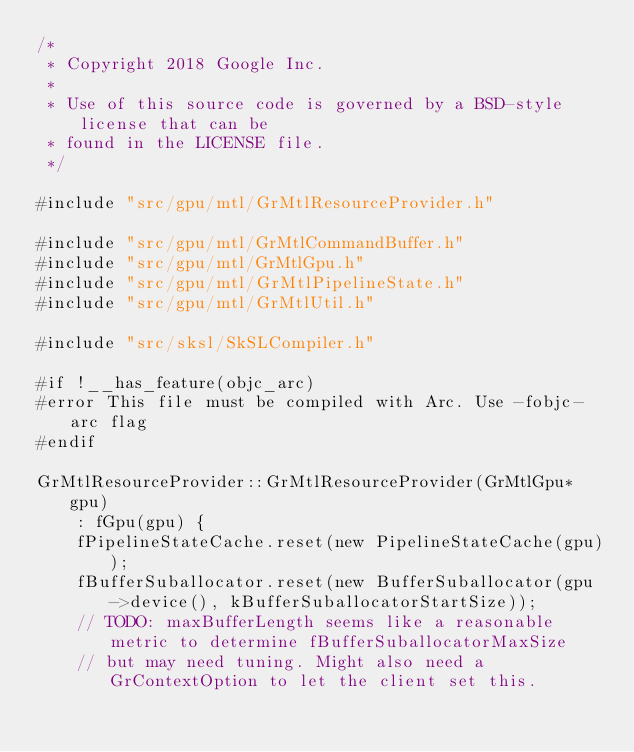Convert code to text. <code><loc_0><loc_0><loc_500><loc_500><_ObjectiveC_>/*
 * Copyright 2018 Google Inc.
 *
 * Use of this source code is governed by a BSD-style license that can be
 * found in the LICENSE file.
 */

#include "src/gpu/mtl/GrMtlResourceProvider.h"

#include "src/gpu/mtl/GrMtlCommandBuffer.h"
#include "src/gpu/mtl/GrMtlGpu.h"
#include "src/gpu/mtl/GrMtlPipelineState.h"
#include "src/gpu/mtl/GrMtlUtil.h"

#include "src/sksl/SkSLCompiler.h"

#if !__has_feature(objc_arc)
#error This file must be compiled with Arc. Use -fobjc-arc flag
#endif

GrMtlResourceProvider::GrMtlResourceProvider(GrMtlGpu* gpu)
    : fGpu(gpu) {
    fPipelineStateCache.reset(new PipelineStateCache(gpu));
    fBufferSuballocator.reset(new BufferSuballocator(gpu->device(), kBufferSuballocatorStartSize));
    // TODO: maxBufferLength seems like a reasonable metric to determine fBufferSuballocatorMaxSize
    // but may need tuning. Might also need a GrContextOption to let the client set this.</code> 